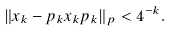<formula> <loc_0><loc_0><loc_500><loc_500>\| x _ { k } - p _ { k } x _ { k } p _ { k } \| _ { p } < 4 ^ { - k } .</formula> 